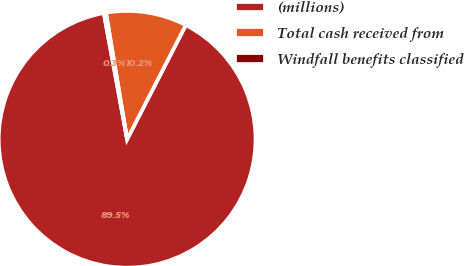<chart> <loc_0><loc_0><loc_500><loc_500><pie_chart><fcel>(millions)<fcel>Total cash received from<fcel>Windfall benefits classified<nl><fcel>89.54%<fcel>10.19%<fcel>0.27%<nl></chart> 